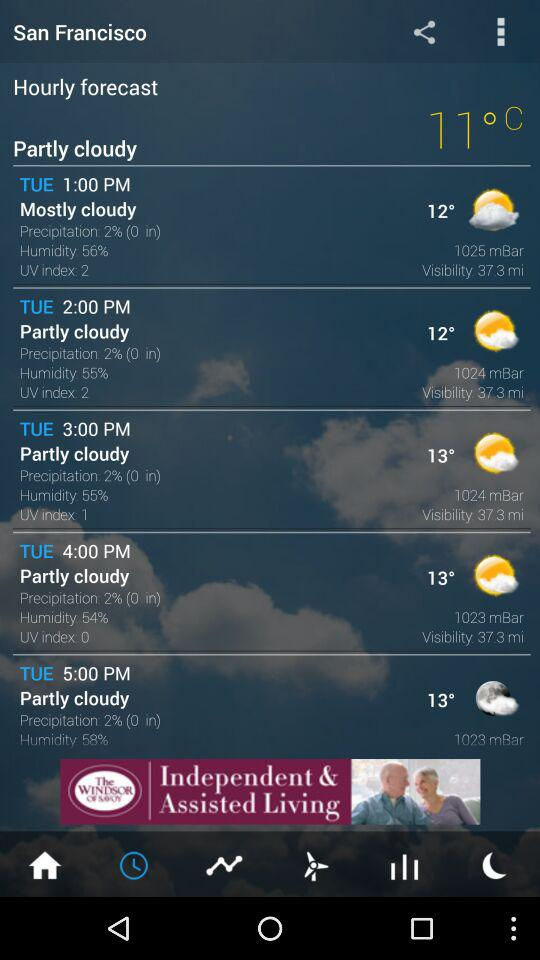What is the precipitation at 5:00 PM on Tuesday? The precipitation is 2%. 